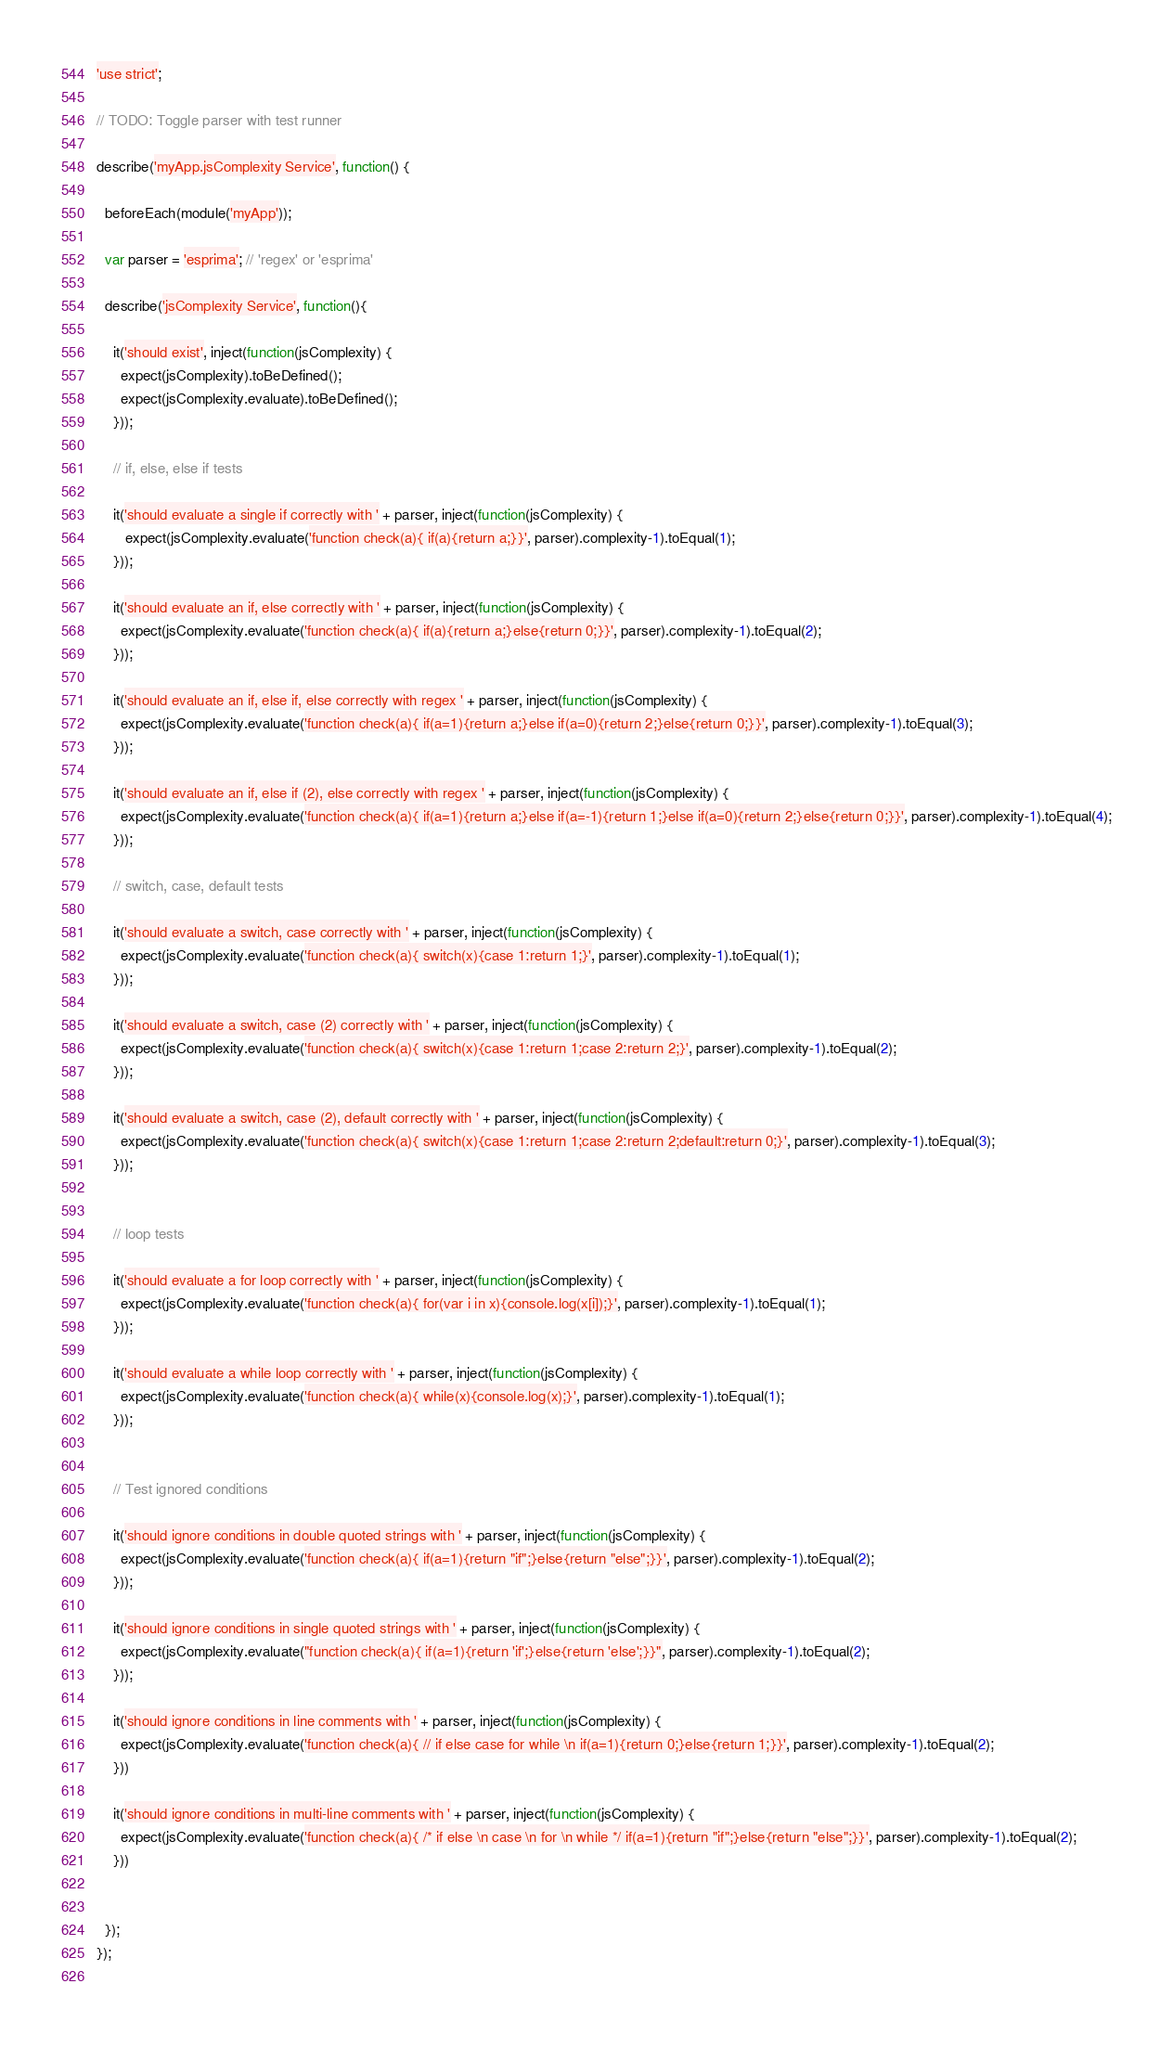Convert code to text. <code><loc_0><loc_0><loc_500><loc_500><_JavaScript_>'use strict';

// TODO: Toggle parser with test runner

describe('myApp.jsComplexity Service', function() {

  beforeEach(module('myApp'));

  var parser = 'esprima'; // 'regex' or 'esprima'

  describe('jsComplexity Service', function(){

    it('should exist', inject(function(jsComplexity) {
      expect(jsComplexity).toBeDefined();
      expect(jsComplexity.evaluate).toBeDefined();
    }));

    // if, else, else if tests
  
    it('should evaluate a single if correctly with ' + parser, inject(function(jsComplexity) {
       expect(jsComplexity.evaluate('function check(a){ if(a){return a;}}', parser).complexity-1).toEqual(1);
    }));
  
    it('should evaluate an if, else correctly with ' + parser, inject(function(jsComplexity) {
      expect(jsComplexity.evaluate('function check(a){ if(a){return a;}else{return 0;}}', parser).complexity-1).toEqual(2);
    }));
  
    it('should evaluate an if, else if, else correctly with regex ' + parser, inject(function(jsComplexity) {
      expect(jsComplexity.evaluate('function check(a){ if(a=1){return a;}else if(a=0){return 2;}else{return 0;}}', parser).complexity-1).toEqual(3);
    }));

    it('should evaluate an if, else if (2), else correctly with regex ' + parser, inject(function(jsComplexity) {
      expect(jsComplexity.evaluate('function check(a){ if(a=1){return a;}else if(a=-1){return 1;}else if(a=0){return 2;}else{return 0;}}', parser).complexity-1).toEqual(4);
    }));

    // switch, case, default tests

    it('should evaluate a switch, case correctly with ' + parser, inject(function(jsComplexity) {
      expect(jsComplexity.evaluate('function check(a){ switch(x){case 1:return 1;}', parser).complexity-1).toEqual(1);
    }));

    it('should evaluate a switch, case (2) correctly with ' + parser, inject(function(jsComplexity) {
      expect(jsComplexity.evaluate('function check(a){ switch(x){case 1:return 1;case 2:return 2;}', parser).complexity-1).toEqual(2);
    }));

    it('should evaluate a switch, case (2), default correctly with ' + parser, inject(function(jsComplexity) {
      expect(jsComplexity.evaluate('function check(a){ switch(x){case 1:return 1;case 2:return 2;default:return 0;}', parser).complexity-1).toEqual(3);
    }));


    // loop tests

    it('should evaluate a for loop correctly with ' + parser, inject(function(jsComplexity) {
      expect(jsComplexity.evaluate('function check(a){ for(var i in x){console.log(x[i]);}', parser).complexity-1).toEqual(1);
    }));

    it('should evaluate a while loop correctly with ' + parser, inject(function(jsComplexity) {
      expect(jsComplexity.evaluate('function check(a){ while(x){console.log(x);}', parser).complexity-1).toEqual(1);
    }));


    // Test ignored conditions

    it('should ignore conditions in double quoted strings with ' + parser, inject(function(jsComplexity) {
      expect(jsComplexity.evaluate('function check(a){ if(a=1){return "if";}else{return "else";}}', parser).complexity-1).toEqual(2);
    }));

    it('should ignore conditions in single quoted strings with ' + parser, inject(function(jsComplexity) {
      expect(jsComplexity.evaluate("function check(a){ if(a=1){return 'if';}else{return 'else';}}", parser).complexity-1).toEqual(2);
    }));

    it('should ignore conditions in line comments with ' + parser, inject(function(jsComplexity) {
      expect(jsComplexity.evaluate('function check(a){ // if else case for while \n if(a=1){return 0;}else{return 1;}}', parser).complexity-1).toEqual(2);
    }))

    it('should ignore conditions in multi-line comments with ' + parser, inject(function(jsComplexity) {
      expect(jsComplexity.evaluate('function check(a){ /* if else \n case \n for \n while */ if(a=1){return "if";}else{return "else";}}', parser).complexity-1).toEqual(2);
    }))


  });
});
  </code> 